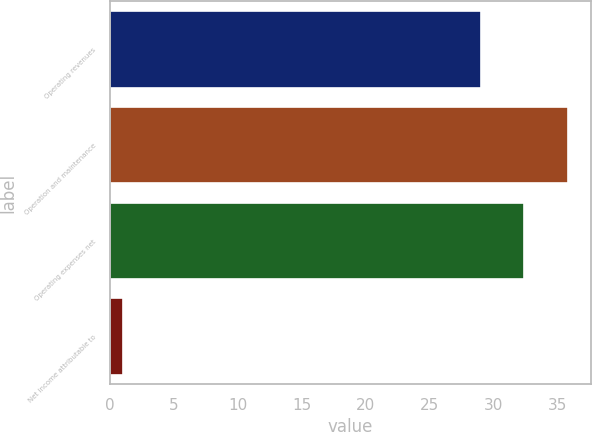Convert chart. <chart><loc_0><loc_0><loc_500><loc_500><bar_chart><fcel>Operating revenues<fcel>Operation and maintenance<fcel>Operating expenses net<fcel>Net income attributable to<nl><fcel>29<fcel>35.8<fcel>32.4<fcel>1<nl></chart> 